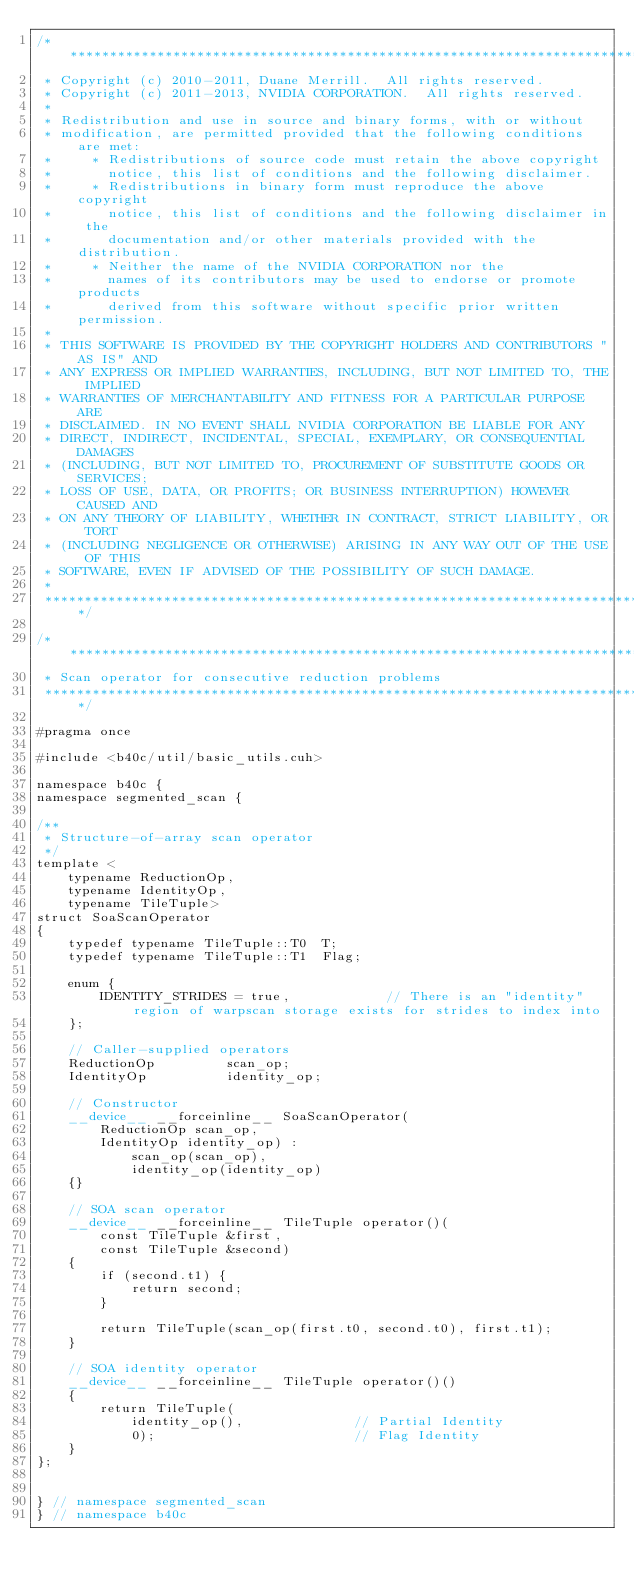Convert code to text. <code><loc_0><loc_0><loc_500><loc_500><_Cuda_>/******************************************************************************
 * Copyright (c) 2010-2011, Duane Merrill.  All rights reserved.
 * Copyright (c) 2011-2013, NVIDIA CORPORATION.  All rights reserved.
 * 
 * Redistribution and use in source and binary forms, with or without
 * modification, are permitted provided that the following conditions are met:
 *     * Redistributions of source code must retain the above copyright
 *       notice, this list of conditions and the following disclaimer.
 *     * Redistributions in binary form must reproduce the above copyright
 *       notice, this list of conditions and the following disclaimer in the
 *       documentation and/or other materials provided with the distribution.
 *     * Neither the name of the NVIDIA CORPORATION nor the
 *       names of its contributors may be used to endorse or promote products
 *       derived from this software without specific prior written permission.
 * 
 * THIS SOFTWARE IS PROVIDED BY THE COPYRIGHT HOLDERS AND CONTRIBUTORS "AS IS" AND
 * ANY EXPRESS OR IMPLIED WARRANTIES, INCLUDING, BUT NOT LIMITED TO, THE IMPLIED
 * WARRANTIES OF MERCHANTABILITY AND FITNESS FOR A PARTICULAR PURPOSE ARE
 * DISCLAIMED. IN NO EVENT SHALL NVIDIA CORPORATION BE LIABLE FOR ANY
 * DIRECT, INDIRECT, INCIDENTAL, SPECIAL, EXEMPLARY, OR CONSEQUENTIAL DAMAGES
 * (INCLUDING, BUT NOT LIMITED TO, PROCUREMENT OF SUBSTITUTE GOODS OR SERVICES;
 * LOSS OF USE, DATA, OR PROFITS; OR BUSINESS INTERRUPTION) HOWEVER CAUSED AND
 * ON ANY THEORY OF LIABILITY, WHETHER IN CONTRACT, STRICT LIABILITY, OR TORT
 * (INCLUDING NEGLIGENCE OR OTHERWISE) ARISING IN ANY WAY OUT OF THE USE OF THIS
 * SOFTWARE, EVEN IF ADVISED OF THE POSSIBILITY OF SUCH DAMAGE.
 *
 ******************************************************************************/

/******************************************************************************
 * Scan operator for consecutive reduction problems
 ******************************************************************************/

#pragma once

#include <b40c/util/basic_utils.cuh>

namespace b40c {
namespace segmented_scan {

/**
 * Structure-of-array scan operator
 */
template <
	typename ReductionOp,
	typename IdentityOp,
	typename TileTuple>
struct SoaScanOperator
{
	typedef typename TileTuple::T0 	T;
	typedef typename TileTuple::T1 	Flag;

	enum {
		IDENTITY_STRIDES = true,			// There is an "identity" region of warpscan storage exists for strides to index into
	};

	// Caller-supplied operators
	ReductionOp 		scan_op;
	IdentityOp 			identity_op;

	// Constructor
	__device__ __forceinline__ SoaScanOperator(
		ReductionOp scan_op,
		IdentityOp identity_op) :
			scan_op(scan_op),
			identity_op(identity_op)
	{}

	// SOA scan operator
	__device__ __forceinline__ TileTuple operator()(
		const TileTuple &first,
		const TileTuple &second)
	{
		if (second.t1) {
			return second;
		}

		return TileTuple(scan_op(first.t0, second.t0), first.t1);
	}

	// SOA identity operator
	__device__ __forceinline__ TileTuple operator()()
	{
		return TileTuple(
			identity_op(),				// Partial Identity
			0);							// Flag Identity
	}
};


} // namespace segmented_scan
} // namespace b40c

</code> 